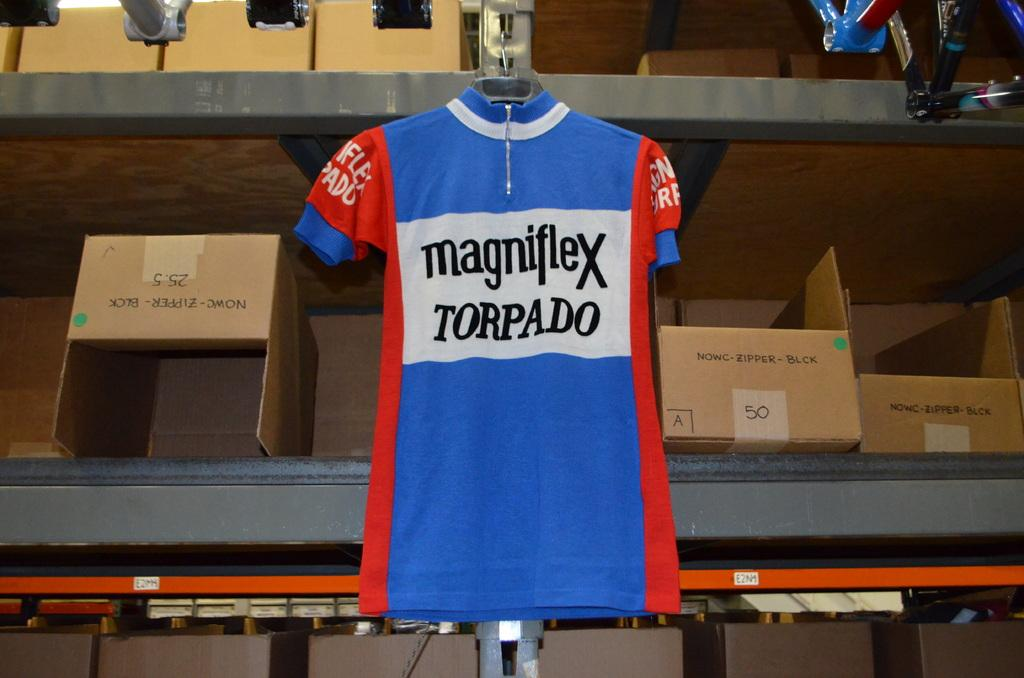<image>
Share a concise interpretation of the image provided. A blue jersey reading magniflex Torpado hangs on a hanger. 